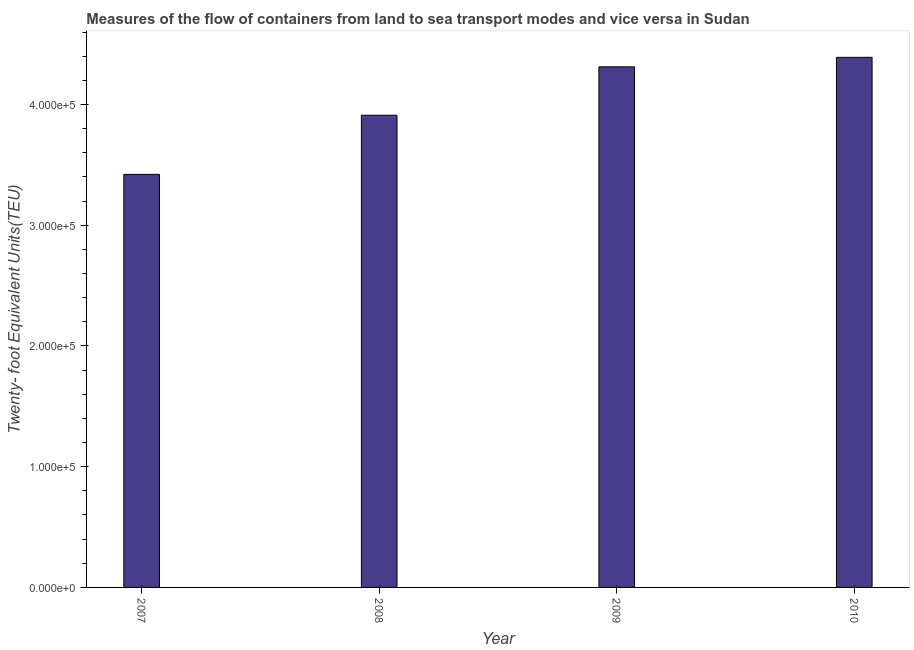Does the graph contain any zero values?
Your answer should be compact. No. Does the graph contain grids?
Provide a short and direct response. No. What is the title of the graph?
Your answer should be compact. Measures of the flow of containers from land to sea transport modes and vice versa in Sudan. What is the label or title of the X-axis?
Make the answer very short. Year. What is the label or title of the Y-axis?
Make the answer very short. Twenty- foot Equivalent Units(TEU). What is the container port traffic in 2010?
Your response must be concise. 4.39e+05. Across all years, what is the maximum container port traffic?
Offer a very short reply. 4.39e+05. Across all years, what is the minimum container port traffic?
Your answer should be very brief. 3.42e+05. In which year was the container port traffic minimum?
Provide a succinct answer. 2007. What is the sum of the container port traffic?
Give a very brief answer. 1.60e+06. What is the difference between the container port traffic in 2007 and 2009?
Offer a very short reply. -8.91e+04. What is the average container port traffic per year?
Ensure brevity in your answer.  4.01e+05. What is the median container port traffic?
Give a very brief answer. 4.11e+05. In how many years, is the container port traffic greater than 320000 TEU?
Provide a succinct answer. 4. What is the ratio of the container port traffic in 2007 to that in 2010?
Your answer should be compact. 0.78. Is the container port traffic in 2008 less than that in 2010?
Your response must be concise. Yes. Is the difference between the container port traffic in 2008 and 2010 greater than the difference between any two years?
Give a very brief answer. No. What is the difference between the highest and the second highest container port traffic?
Your answer should be very brief. 7868. What is the difference between the highest and the lowest container port traffic?
Ensure brevity in your answer.  9.69e+04. How many bars are there?
Make the answer very short. 4. Are all the bars in the graph horizontal?
Make the answer very short. No. How many years are there in the graph?
Your answer should be compact. 4. What is the difference between two consecutive major ticks on the Y-axis?
Provide a short and direct response. 1.00e+05. What is the Twenty- foot Equivalent Units(TEU) of 2007?
Your answer should be compact. 3.42e+05. What is the Twenty- foot Equivalent Units(TEU) in 2008?
Give a very brief answer. 3.91e+05. What is the Twenty- foot Equivalent Units(TEU) of 2009?
Offer a very short reply. 4.31e+05. What is the Twenty- foot Equivalent Units(TEU) of 2010?
Keep it short and to the point. 4.39e+05. What is the difference between the Twenty- foot Equivalent Units(TEU) in 2007 and 2008?
Provide a succinct answer. -4.90e+04. What is the difference between the Twenty- foot Equivalent Units(TEU) in 2007 and 2009?
Your response must be concise. -8.91e+04. What is the difference between the Twenty- foot Equivalent Units(TEU) in 2007 and 2010?
Keep it short and to the point. -9.69e+04. What is the difference between the Twenty- foot Equivalent Units(TEU) in 2008 and 2009?
Make the answer very short. -4.01e+04. What is the difference between the Twenty- foot Equivalent Units(TEU) in 2008 and 2010?
Make the answer very short. -4.80e+04. What is the difference between the Twenty- foot Equivalent Units(TEU) in 2009 and 2010?
Give a very brief answer. -7868. What is the ratio of the Twenty- foot Equivalent Units(TEU) in 2007 to that in 2008?
Make the answer very short. 0.88. What is the ratio of the Twenty- foot Equivalent Units(TEU) in 2007 to that in 2009?
Your answer should be compact. 0.79. What is the ratio of the Twenty- foot Equivalent Units(TEU) in 2007 to that in 2010?
Provide a succinct answer. 0.78. What is the ratio of the Twenty- foot Equivalent Units(TEU) in 2008 to that in 2009?
Provide a succinct answer. 0.91. What is the ratio of the Twenty- foot Equivalent Units(TEU) in 2008 to that in 2010?
Provide a succinct answer. 0.89. 